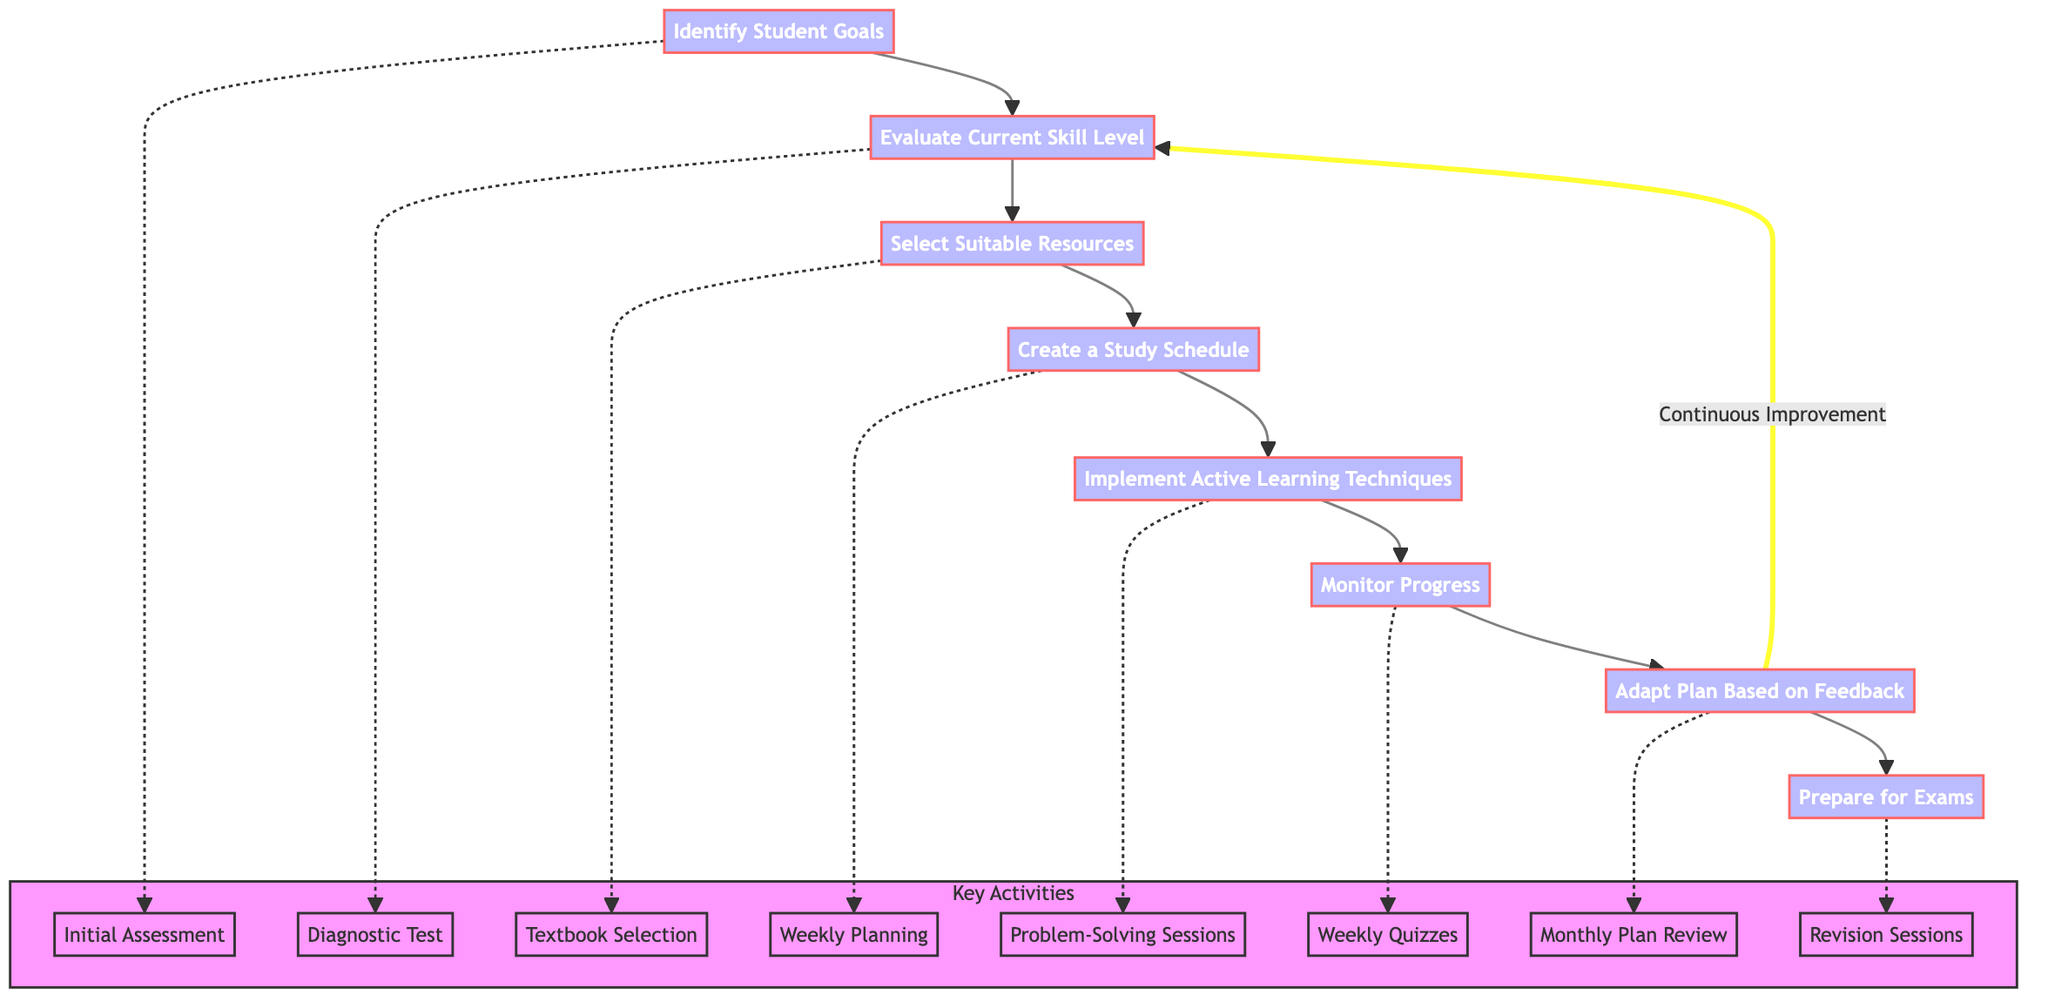What is the first step in the study plan? The first step is to identify student goals, which involves determining specific math areas for improvement and setting clear, achievable goals.
Answer: Identify Student Goals How many nodes are in the flowchart? The flowchart contains eight nodes, each representing a step in the personalized study plan for math.
Answer: Eight What is the last step described in the flowchart? The last step is "Prepare for Exams," which focuses on allocating time for revision and practice tests before exams.
Answer: Prepare for Exams Which activity is related to the "Evaluate Current Skill Level" step? The activities related to this step include "Diagnostic Test," which is used to assess the student's current math skills.
Answer: Diagnostic Test What happens after "Monitor Progress"? After "Monitor Progress," the next step is to "Adapt Plan Based on Feedback," indicating that progress review leads to adjustments in the study plan.
Answer: Adapt Plan Based on Feedback List one activity associated with the "Create a Study Schedule" step. One activity associated with this step is "Weekly Planning," which involves developing a timetable for study sessions.
Answer: Weekly Planning What process follows the "Implement Active Learning Techniques"? The process that follows the "Implement Active Learning Techniques" is "Monitor Progress," representing the need to track understanding and improvements after applying active learning methods.
Answer: Monitor Progress How does "Adapt Plan Based on Feedback" relate to "Evaluate Current Skill Level"? "Adapt Plan Based on Feedback" loops back to "Evaluate Current Skill Level" for continuous improvement, indicating an iterative process of assessing and adapting based on progress.
Answer: Continuous Improvement 